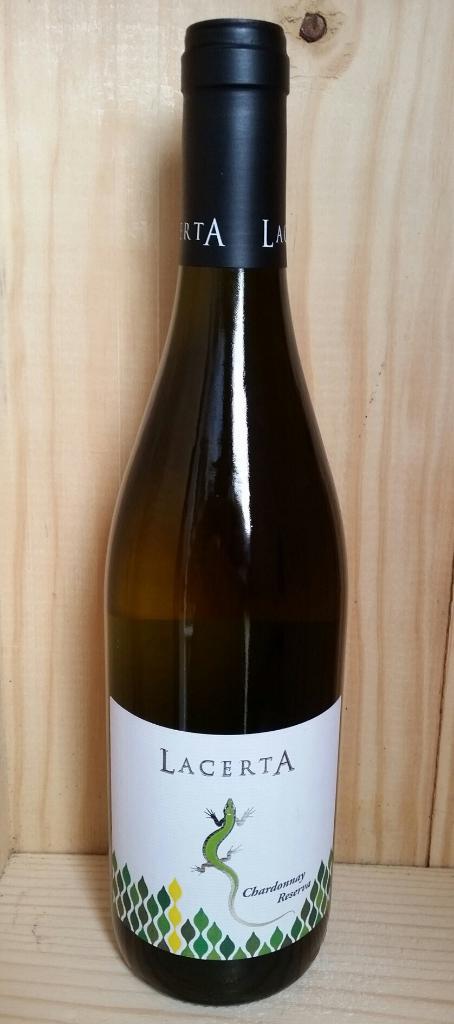What is the brand name of the wine?
Your answer should be compact. Lacerta. 